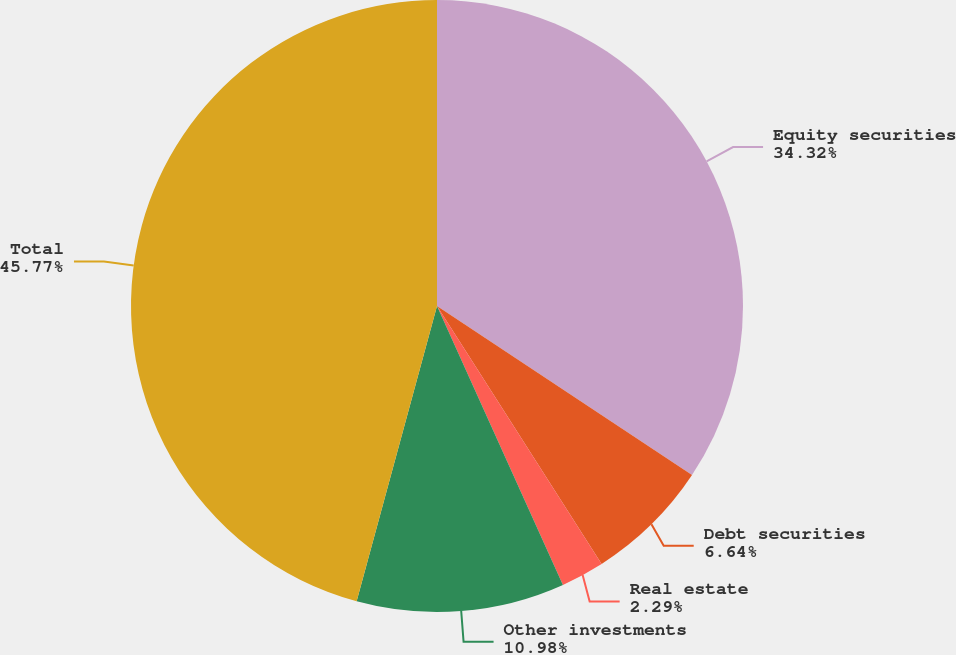<chart> <loc_0><loc_0><loc_500><loc_500><pie_chart><fcel>Equity securities<fcel>Debt securities<fcel>Real estate<fcel>Other investments<fcel>Total<nl><fcel>34.32%<fcel>6.64%<fcel>2.29%<fcel>10.98%<fcel>45.77%<nl></chart> 